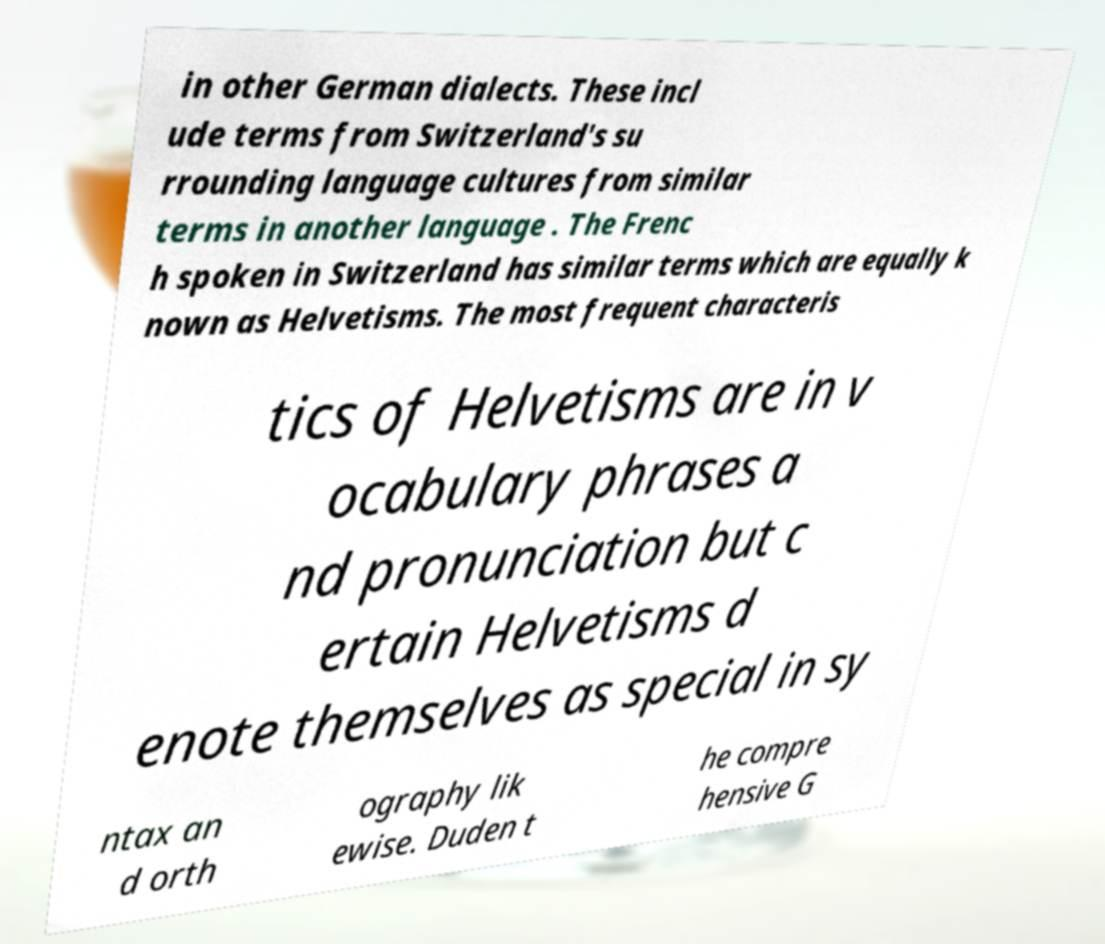Please identify and transcribe the text found in this image. in other German dialects. These incl ude terms from Switzerland's su rrounding language cultures from similar terms in another language . The Frenc h spoken in Switzerland has similar terms which are equally k nown as Helvetisms. The most frequent characteris tics of Helvetisms are in v ocabulary phrases a nd pronunciation but c ertain Helvetisms d enote themselves as special in sy ntax an d orth ography lik ewise. Duden t he compre hensive G 